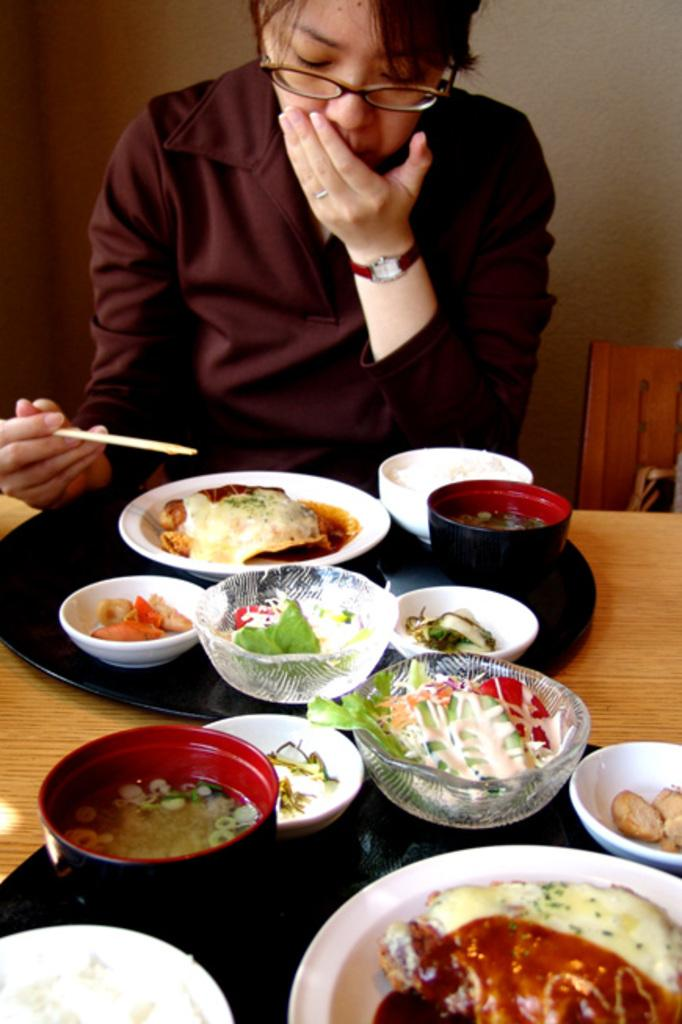What is the woman in the image doing? The woman is sitting on a chair. What is the woman holding in the image? The woman is holding chopsticks. What can be seen on the table in the image? There are bowls and a plate on the table. What is present on the table that indicates food is involved? There is food on the table. What type of record is the woman listening to in the image? There is no record present in the image; the woman is holding chopsticks and there is food on the table. 